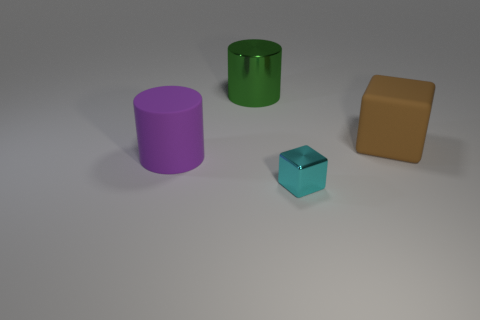Add 2 small things. How many objects exist? 6 Subtract all cyan cylinders. Subtract all blue spheres. How many cylinders are left? 2 Subtract all cyan cylinders. How many green cubes are left? 0 Subtract all purple shiny things. Subtract all large cylinders. How many objects are left? 2 Add 3 matte cylinders. How many matte cylinders are left? 4 Add 4 rubber things. How many rubber things exist? 6 Subtract 1 brown blocks. How many objects are left? 3 